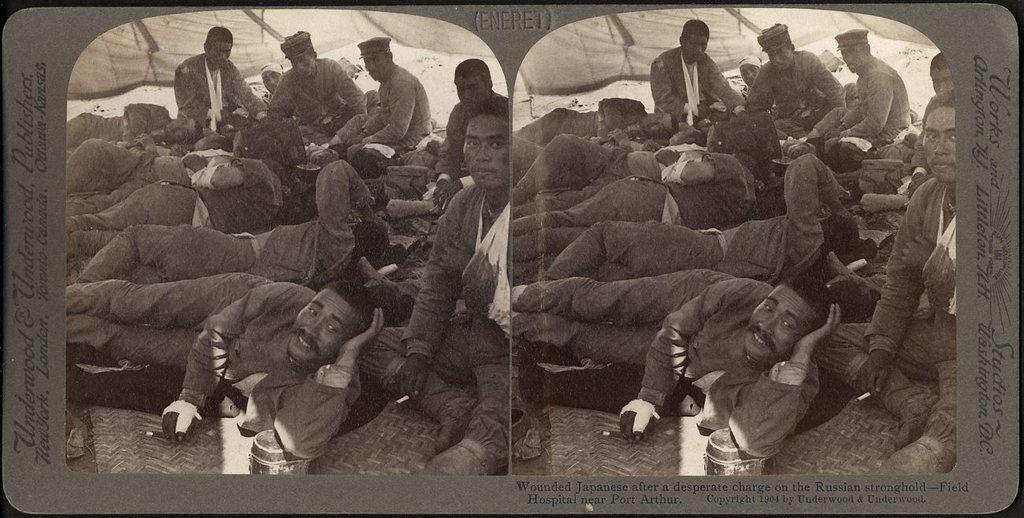Please provide a concise description of this image. On the left side of the image we can see some people are taking rest and some of them are sitting and some text was written on it. On the right side of the image we can see some people are sitting and some of them are taking rest and a text was written on it. 